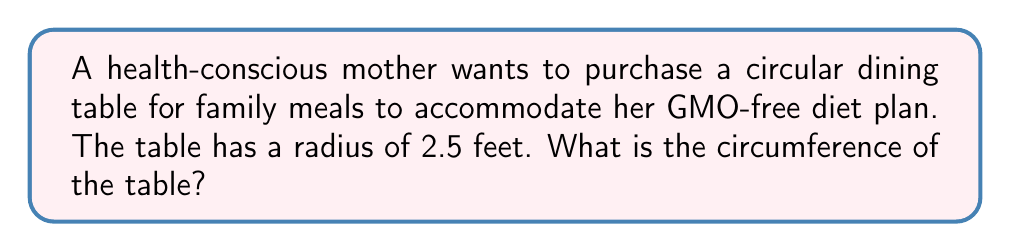Teach me how to tackle this problem. To find the circumference of a circular table, we use the formula:

$$ C = 2\pi r $$

Where:
$C$ is the circumference
$\pi$ is approximately 3.14159
$r$ is the radius of the circle

Given:
$r = 2.5$ feet

Step 1: Substitute the known values into the formula
$$ C = 2\pi (2.5) $$

Step 2: Multiply
$$ C = 5\pi $$

Step 3: Calculate the final value (using $\pi \approx 3.14159$)
$$ C \approx 5 \times 3.14159 = 15.70795 \text{ feet} $$

Therefore, the circumference of the circular dining table is approximately 15.71 feet.

[asy]
import geometry;

size(100);
draw(circle((0,0), 2.5), blue);
draw((0,0)--(2.5,0), arrow=Arrow(TeXHead));
label("r = 2.5 ft", (1.25,0.3), N);
label("C ≈ 15.71 ft", (0,-2.8), S);
[/asy]
Answer: $15.71 \text{ feet}$ 